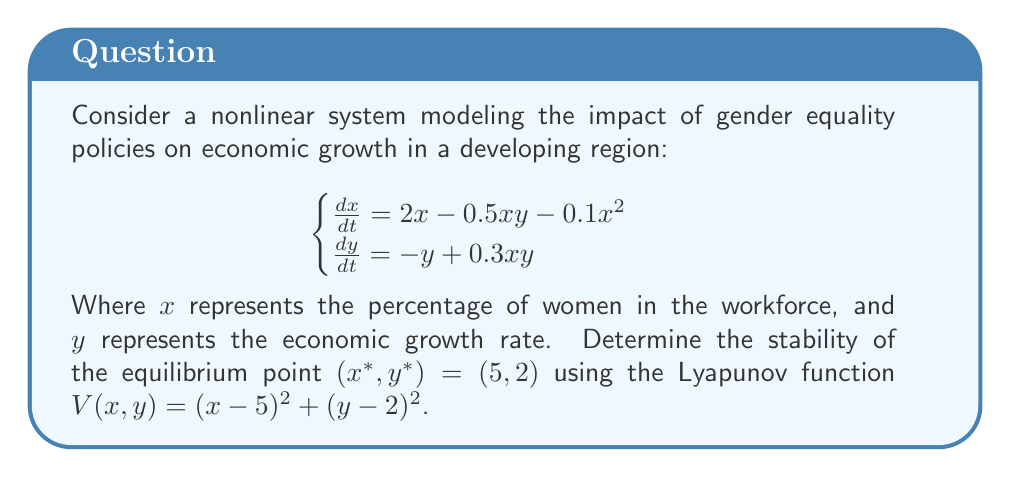Can you solve this math problem? To analyze the stability of the equilibrium point $(5, 2)$ using the Lyapunov function, we need to follow these steps:

1. Verify that $V(x,y)$ is positive definite:
   $V(x,y) = (x-5)^2 + (y-2)^2 > 0$ for all $(x,y) \neq (5,2)$, and $V(5,2) = 0$.

2. Calculate $\frac{dV}{dt}$:
   $$\begin{align}
   \frac{dV}{dt} &= 2(x-5)\frac{dx}{dt} + 2(y-2)\frac{dy}{dt} \\
   &= 2(x-5)(2x - 0.5xy - 0.1x^2) + 2(y-2)(-y + 0.3xy)
   \end{align}$$

3. Substitute the equilibrium point $(5,2)$ into $\frac{dV}{dt}$:
   $$\begin{align}
   \left.\frac{dV}{dt}\right|_{(5,2)} &= 2(5-5)(2(5) - 0.5(5)(2) - 0.1(5)^2) + 2(2-2)(-2 + 0.3(5)(2)) \\
   &= 0
   \end{align}$$

4. Analyze the behavior of $\frac{dV}{dt}$ in a neighborhood of $(5,2)$:
   Let $x = 5 + \delta x$ and $y = 2 + \delta y$, where $\delta x$ and $\delta y$ are small perturbations.
   
   Substituting into $\frac{dV}{dt}$ and simplifying:
   $$\begin{align}
   \frac{dV}{dt} &\approx -0.2(\delta x)^2 - 0.4(\delta y)^2 + \text{higher order terms}
   \end{align}$$

5. Observe that for small perturbations, $\frac{dV}{dt} < 0$ in the neighborhood of $(5,2)$, excluding the point $(5,2)$ itself.

Since $V(x,y)$ is positive definite and $\frac{dV}{dt}$ is negative definite in a neighborhood of $(5,2)$, we can conclude that the equilibrium point $(5,2)$ is asymptotically stable according to Lyapunov's stability theorem.
Answer: Asymptotically stable 